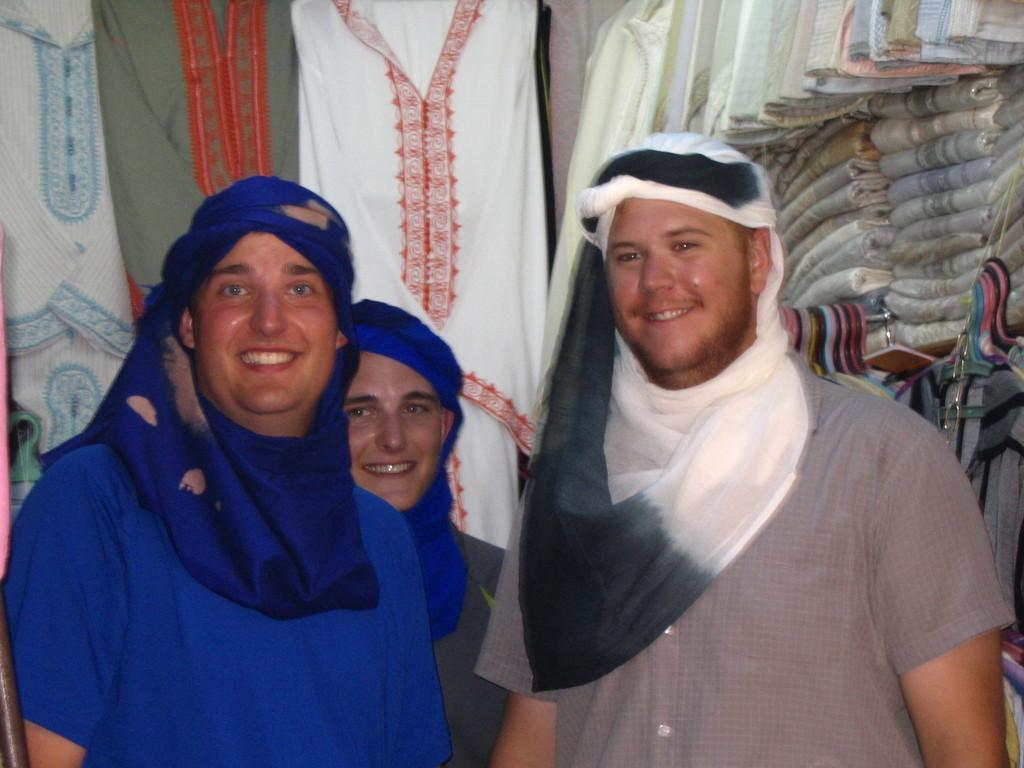Could you give a brief overview of what you see in this image? In this picture, we see three men are standing. Three of them are smiling. Behind them, we see clothes hanged to the hanger. On the right side, we see clothes placed in the rack. 